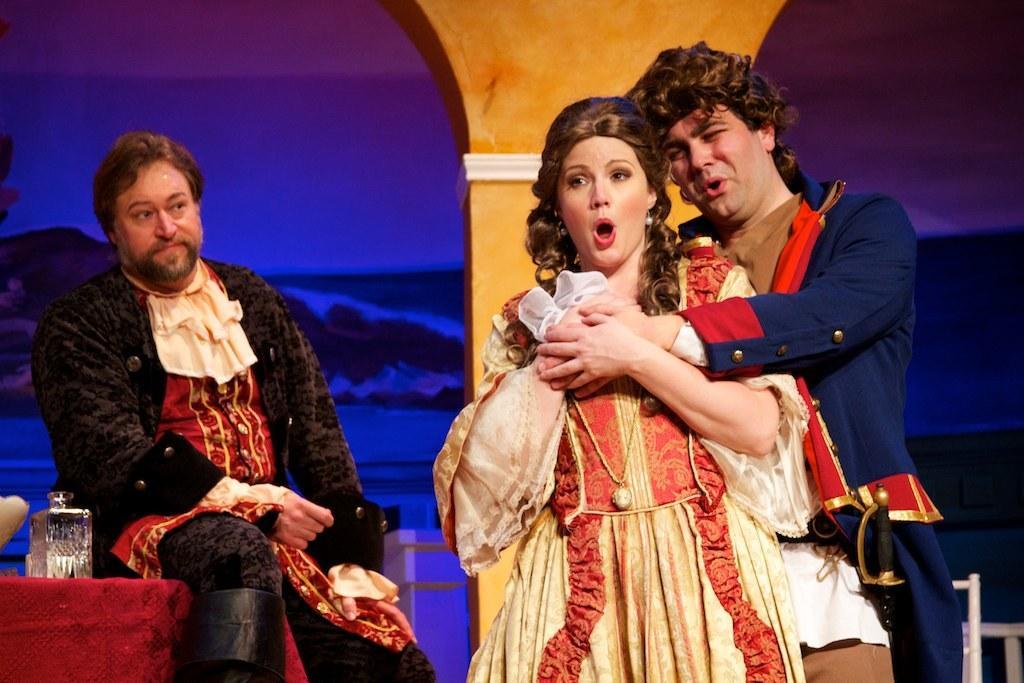How would you summarize this image in a sentence or two? This picture is clicked outside. On the right we can see the two persons wearing dresses of different colors and standing. On the left there is a man wearing a black color jacket and sitting and there are some items placed on the top of the red color table. In the background we can see a pillar and some other objects. 